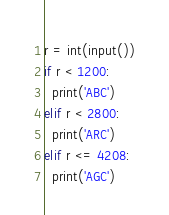Convert code to text. <code><loc_0><loc_0><loc_500><loc_500><_Python_>r = int(input())
if r < 1200:
  print('ABC')
elif r < 2800:
  print('ARC')
elif r <= 4208:
  print('AGC')</code> 